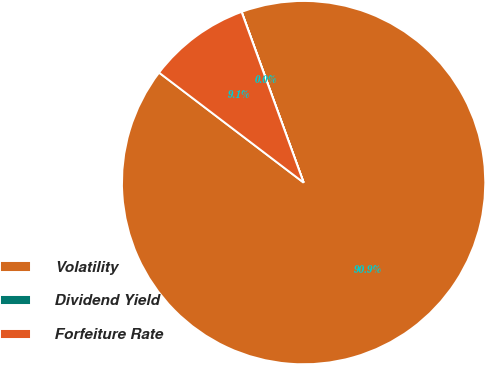<chart> <loc_0><loc_0><loc_500><loc_500><pie_chart><fcel>Volatility<fcel>Dividend Yield<fcel>Forfeiture Rate<nl><fcel>90.89%<fcel>0.01%<fcel>9.1%<nl></chart> 